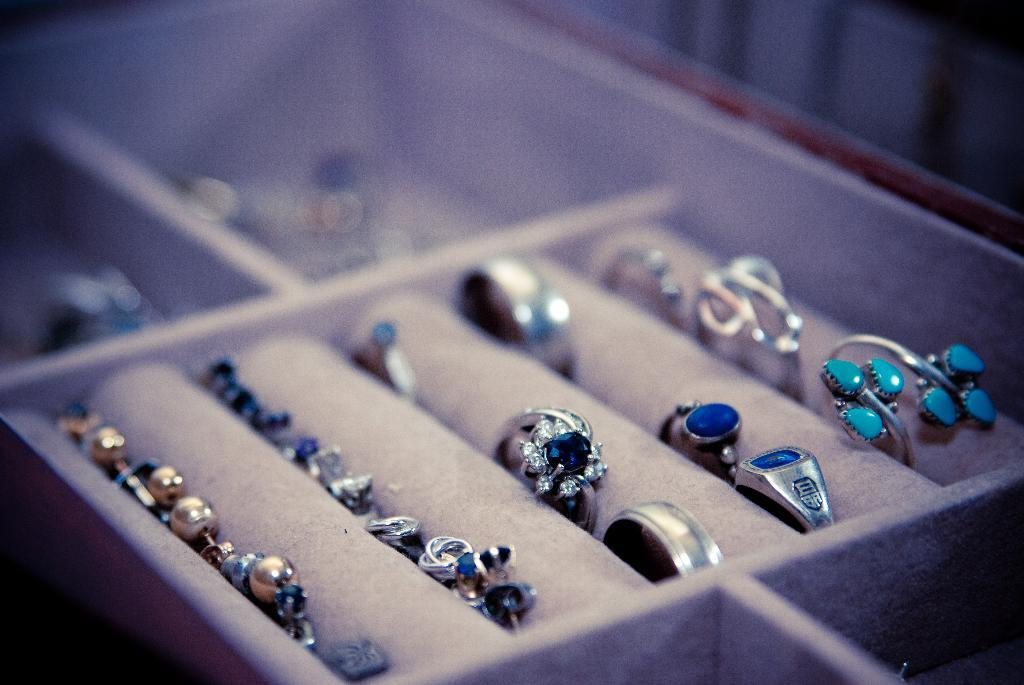What type of items can be seen in the image? There are jewelry items in the image. Can you identify any specific type of jewelry in the image? Yes, there are rings in the image. What type of rhythm can be heard coming from the jewelry in the image? There is no sound or rhythm associated with the jewelry in the image. 